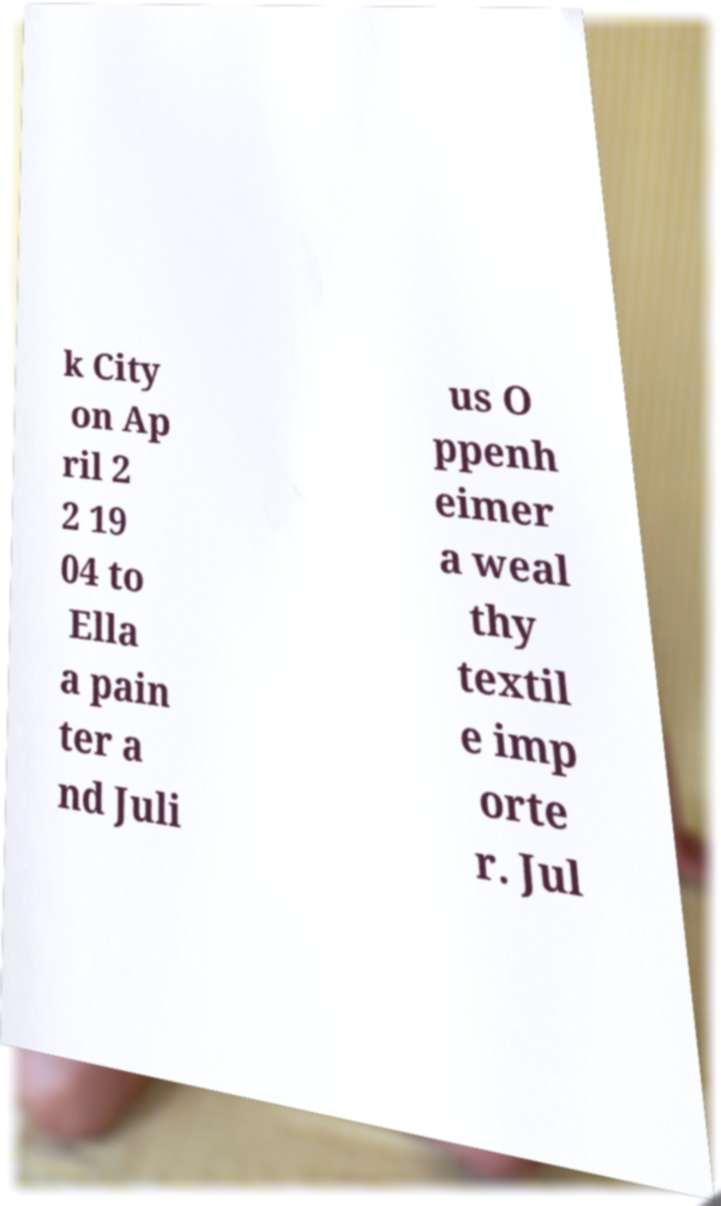Could you assist in decoding the text presented in this image and type it out clearly? k City on Ap ril 2 2 19 04 to Ella a pain ter a nd Juli us O ppenh eimer a weal thy textil e imp orte r. Jul 